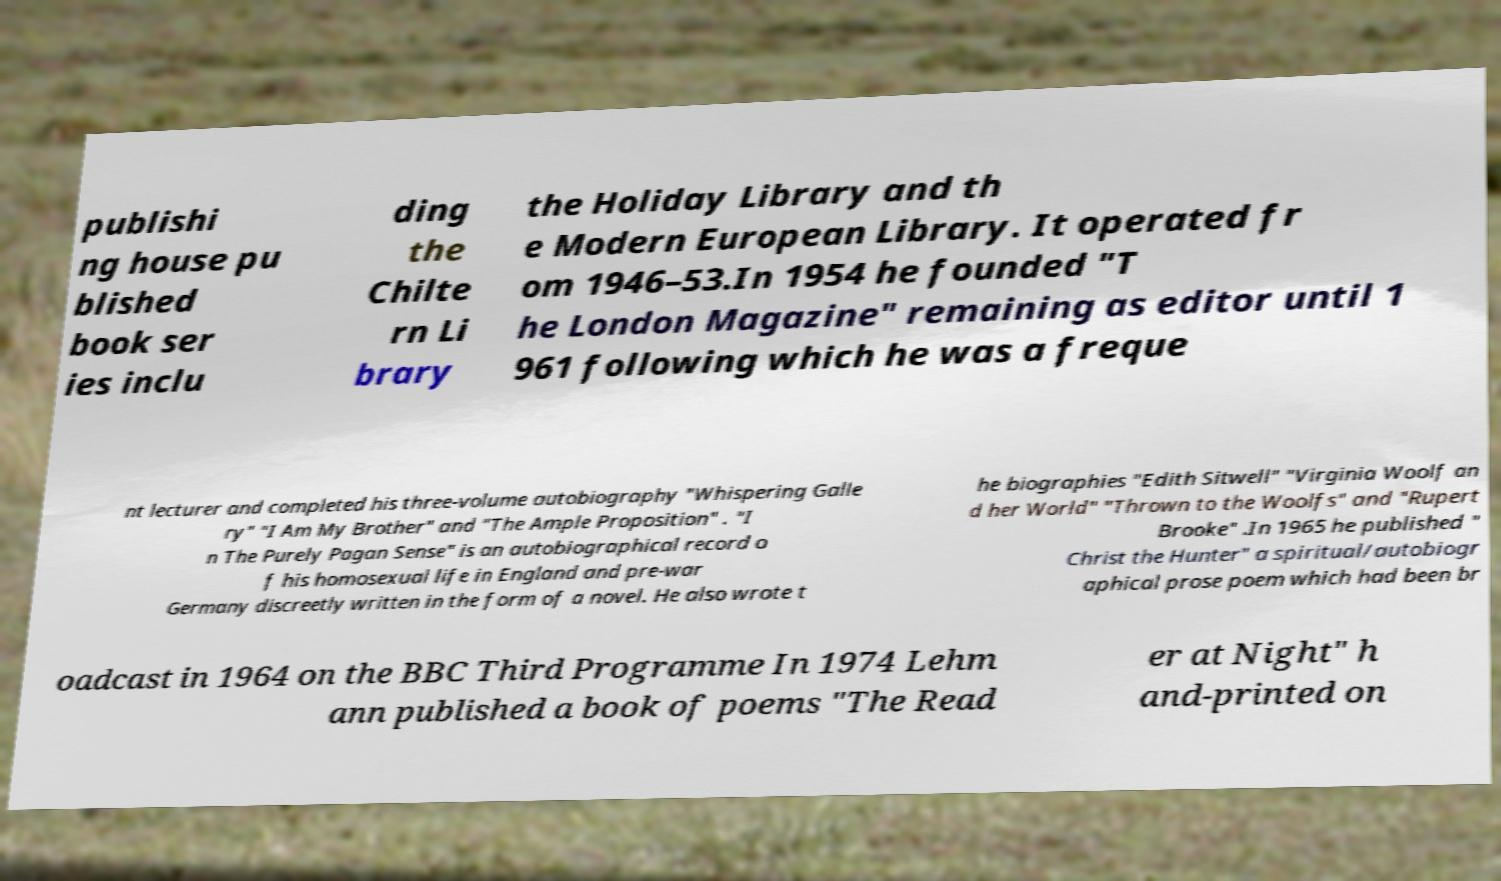Could you assist in decoding the text presented in this image and type it out clearly? publishi ng house pu blished book ser ies inclu ding the Chilte rn Li brary the Holiday Library and th e Modern European Library. It operated fr om 1946–53.In 1954 he founded "T he London Magazine" remaining as editor until 1 961 following which he was a freque nt lecturer and completed his three-volume autobiography "Whispering Galle ry" "I Am My Brother" and "The Ample Proposition" . "I n The Purely Pagan Sense" is an autobiographical record o f his homosexual life in England and pre-war Germany discreetly written in the form of a novel. He also wrote t he biographies "Edith Sitwell" "Virginia Woolf an d her World" "Thrown to the Woolfs" and "Rupert Brooke" .In 1965 he published " Christ the Hunter" a spiritual/autobiogr aphical prose poem which had been br oadcast in 1964 on the BBC Third Programme In 1974 Lehm ann published a book of poems "The Read er at Night" h and-printed on 